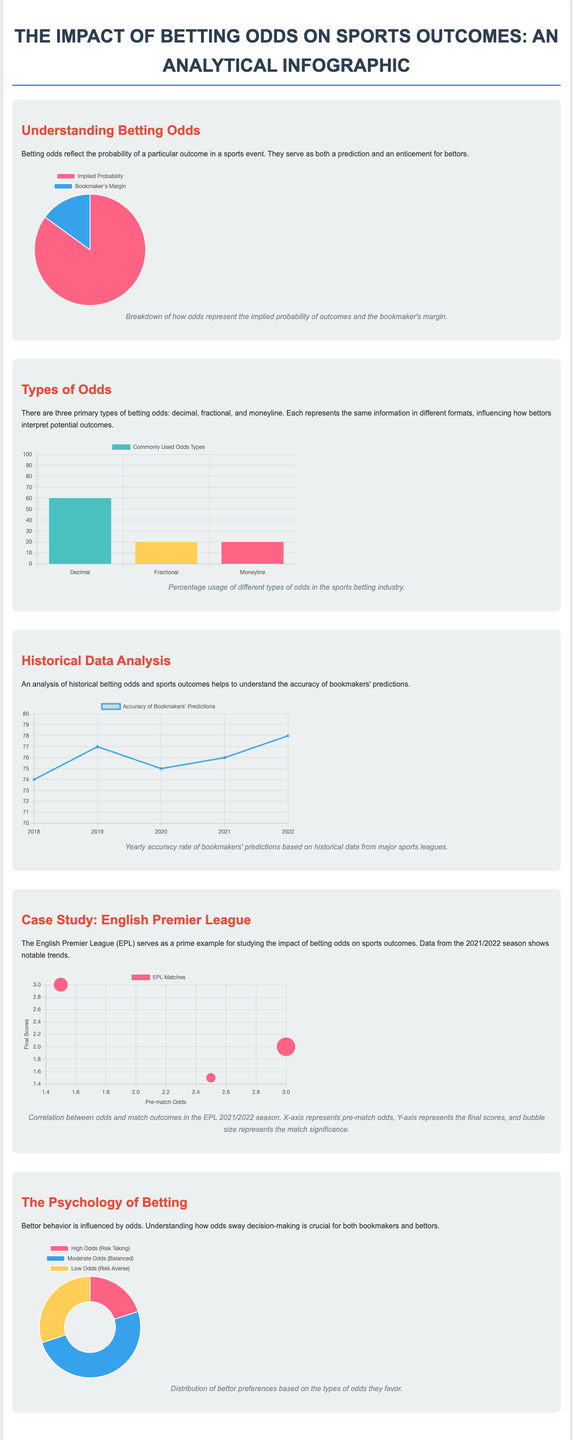What is the primary purpose of betting odds? Betting odds reflect the probability of a particular outcome in a sports event and serve as both a prediction and an enticement for bettors.
Answer: Probability prediction What percentage of bettors prefer decimal odds? The chart indicates the commonly used odds types with a specific percentage for decimal odds.
Answer: 60 What is the historical accuracy rate of bookmakers' predictions in 2022? The provided line chart shows the yearly accuracy rate of bookmakers' predictions across the years, where 2022 has a specific value.
Answer: 78 What is the bubble size in the case study chart related to? The bubble size in the EPL case study chart represents the match significance based on pre-match odds and final scores.
Answer: Match significance Which type of odds has the lowest percentage usage? The chart identifying the various types of odds shows their usage, revealing which has the least percentage.
Answer: Fractional What trend is visible in the historical data analysis from 2018 to 2022? By analyzing the accuracy chart, we can discern the trend in the accuracy rates over the specified years.
Answer: Increasing accuracy What influences bettor behavior according to the infographic? The infographic describes factors that sway bettor decision-making, indicating a key influence on their choices.
Answer: Odds Which type of odds do 50% of bettors prefer? The psychology chart outlines bettor preferences towards various types of odds, highlighting a specific type that is favored by half.
Answer: Moderate Odds 